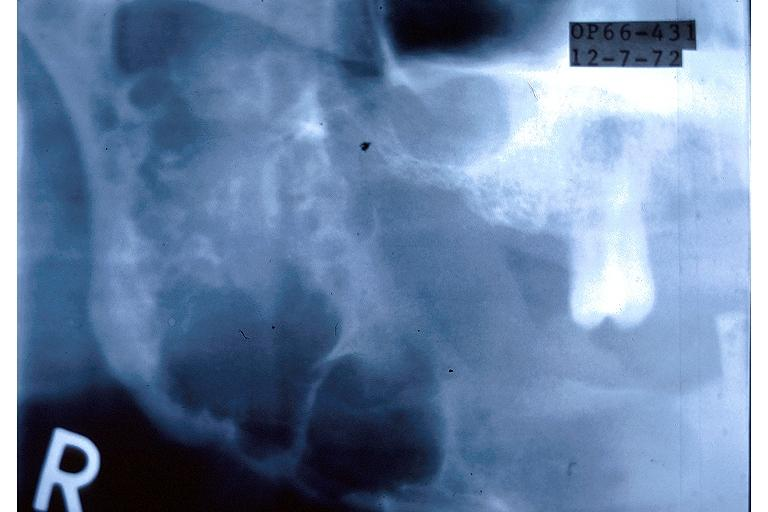does lupus erythematosus periarterial fibrosis show ameloblastoma?
Answer the question using a single word or phrase. No 